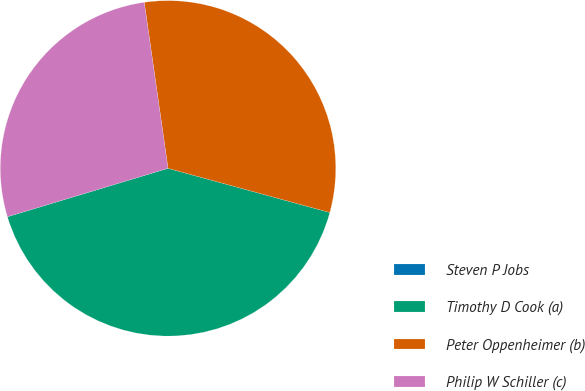<chart> <loc_0><loc_0><loc_500><loc_500><pie_chart><fcel>Steven P Jobs<fcel>Timothy D Cook (a)<fcel>Peter Oppenheimer (b)<fcel>Philip W Schiller (c)<nl><fcel>0.0%<fcel>41.1%<fcel>31.51%<fcel>27.4%<nl></chart> 